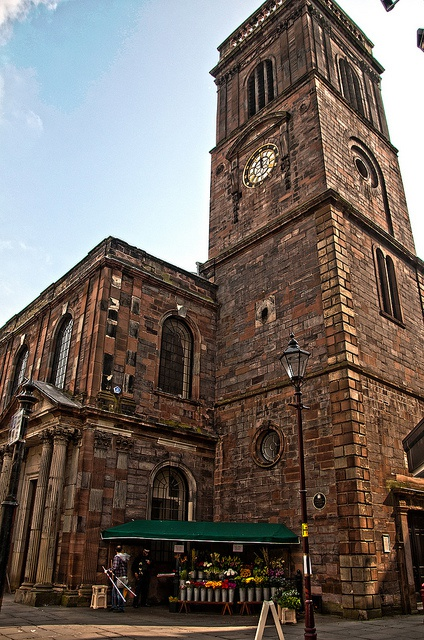Describe the objects in this image and their specific colors. I can see clock in lightgray, black, ivory, and gray tones and people in lightgray, black, maroon, and gray tones in this image. 